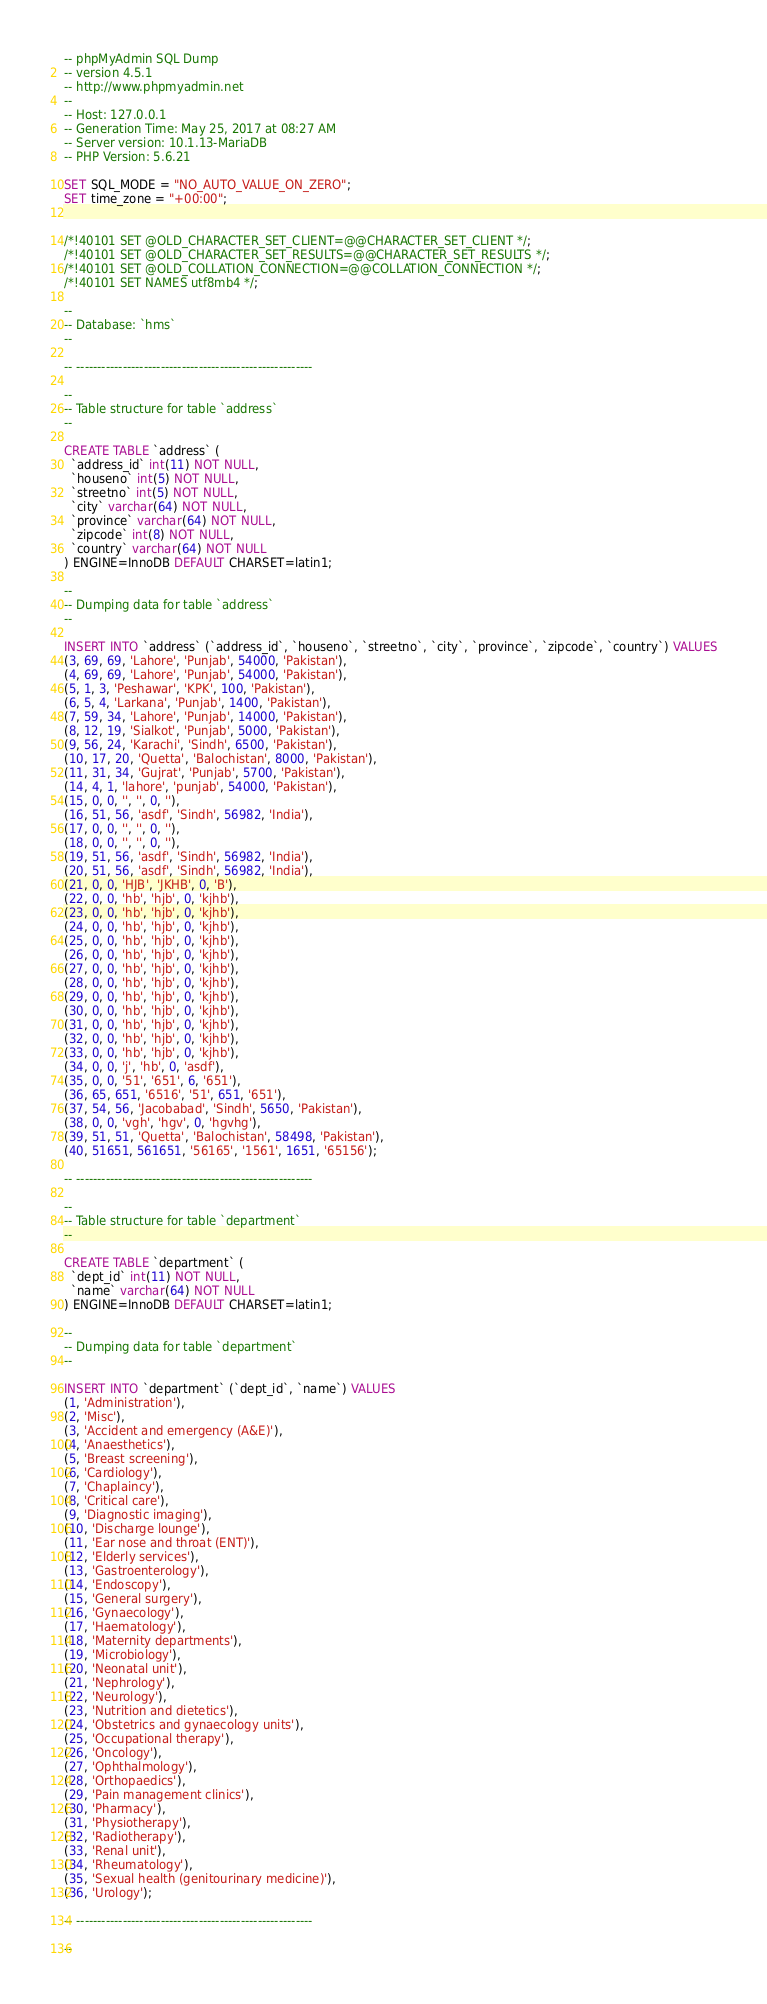<code> <loc_0><loc_0><loc_500><loc_500><_SQL_>-- phpMyAdmin SQL Dump
-- version 4.5.1
-- http://www.phpmyadmin.net
--
-- Host: 127.0.0.1
-- Generation Time: May 25, 2017 at 08:27 AM
-- Server version: 10.1.13-MariaDB
-- PHP Version: 5.6.21

SET SQL_MODE = "NO_AUTO_VALUE_ON_ZERO";
SET time_zone = "+00:00";


/*!40101 SET @OLD_CHARACTER_SET_CLIENT=@@CHARACTER_SET_CLIENT */;
/*!40101 SET @OLD_CHARACTER_SET_RESULTS=@@CHARACTER_SET_RESULTS */;
/*!40101 SET @OLD_COLLATION_CONNECTION=@@COLLATION_CONNECTION */;
/*!40101 SET NAMES utf8mb4 */;

--
-- Database: `hms`
--

-- --------------------------------------------------------

--
-- Table structure for table `address`
--

CREATE TABLE `address` (
  `address_id` int(11) NOT NULL,
  `houseno` int(5) NOT NULL,
  `streetno` int(5) NOT NULL,
  `city` varchar(64) NOT NULL,
  `province` varchar(64) NOT NULL,
  `zipcode` int(8) NOT NULL,
  `country` varchar(64) NOT NULL
) ENGINE=InnoDB DEFAULT CHARSET=latin1;

--
-- Dumping data for table `address`
--

INSERT INTO `address` (`address_id`, `houseno`, `streetno`, `city`, `province`, `zipcode`, `country`) VALUES
(3, 69, 69, 'Lahore', 'Punjab', 54000, 'Pakistan'),
(4, 69, 69, 'Lahore', 'Punjab', 54000, 'Pakistan'),
(5, 1, 3, 'Peshawar', 'KPK', 100, 'Pakistan'),
(6, 5, 4, 'Larkana', 'Punjab', 1400, 'Pakistan'),
(7, 59, 34, 'Lahore', 'Punjab', 14000, 'Pakistan'),
(8, 12, 19, 'Sialkot', 'Punjab', 5000, 'Pakistan'),
(9, 56, 24, 'Karachi', 'Sindh', 6500, 'Pakistan'),
(10, 17, 20, 'Quetta', 'Balochistan', 8000, 'Pakistan'),
(11, 31, 34, 'Gujrat', 'Punjab', 5700, 'Pakistan'),
(14, 4, 1, 'lahore', 'punjab', 54000, 'Pakistan'),
(15, 0, 0, '', '', 0, ''),
(16, 51, 56, 'asdf', 'Sindh', 56982, 'India'),
(17, 0, 0, '', '', 0, ''),
(18, 0, 0, '', '', 0, ''),
(19, 51, 56, 'asdf', 'Sindh', 56982, 'India'),
(20, 51, 56, 'asdf', 'Sindh', 56982, 'India'),
(21, 0, 0, 'HJB', 'JKHB', 0, 'B'),
(22, 0, 0, 'hb', 'hjb', 0, 'kjhb'),
(23, 0, 0, 'hb', 'hjb', 0, 'kjhb'),
(24, 0, 0, 'hb', 'hjb', 0, 'kjhb'),
(25, 0, 0, 'hb', 'hjb', 0, 'kjhb'),
(26, 0, 0, 'hb', 'hjb', 0, 'kjhb'),
(27, 0, 0, 'hb', 'hjb', 0, 'kjhb'),
(28, 0, 0, 'hb', 'hjb', 0, 'kjhb'),
(29, 0, 0, 'hb', 'hjb', 0, 'kjhb'),
(30, 0, 0, 'hb', 'hjb', 0, 'kjhb'),
(31, 0, 0, 'hb', 'hjb', 0, 'kjhb'),
(32, 0, 0, 'hb', 'hjb', 0, 'kjhb'),
(33, 0, 0, 'hb', 'hjb', 0, 'kjhb'),
(34, 0, 0, 'j', 'hb', 0, 'asdf'),
(35, 0, 0, '51', '651', 6, '651'),
(36, 65, 651, '6516', '51', 651, '651'),
(37, 54, 56, 'Jacobabad', 'Sindh', 5650, 'Pakistan'),
(38, 0, 0, 'vgh', 'hgv', 0, 'hgvhg'),
(39, 51, 51, 'Quetta', 'Balochistan', 58498, 'Pakistan'),
(40, 51651, 561651, '56165', '1561', 1651, '65156');

-- --------------------------------------------------------

--
-- Table structure for table `department`
--

CREATE TABLE `department` (
  `dept_id` int(11) NOT NULL,
  `name` varchar(64) NOT NULL
) ENGINE=InnoDB DEFAULT CHARSET=latin1;

--
-- Dumping data for table `department`
--

INSERT INTO `department` (`dept_id`, `name`) VALUES
(1, 'Administration'),
(2, 'Misc'),
(3, 'Accident and emergency (A&E)'),
(4, 'Anaesthetics'),
(5, 'Breast screening'),
(6, 'Cardiology'),
(7, 'Chaplaincy'),
(8, 'Critical care'),
(9, 'Diagnostic imaging'),
(10, 'Discharge lounge'),
(11, 'Ear nose and throat (ENT)'),
(12, 'Elderly services'),
(13, 'Gastroenterology'),
(14, 'Endoscopy'),
(15, 'General surgery'),
(16, 'Gynaecology'),
(17, 'Haematology'),
(18, 'Maternity departments'),
(19, 'Microbiology'),
(20, 'Neonatal unit'),
(21, 'Nephrology'),
(22, 'Neurology'),
(23, 'Nutrition and dietetics'),
(24, 'Obstetrics and gynaecology units'),
(25, 'Occupational therapy'),
(26, 'Oncology'),
(27, 'Ophthalmology'),
(28, 'Orthopaedics'),
(29, 'Pain management clinics'),
(30, 'Pharmacy'),
(31, 'Physiotherapy'),
(32, 'Radiotherapy'),
(33, 'Renal unit'),
(34, 'Rheumatology'),
(35, 'Sexual health (genitourinary medicine)'),
(36, 'Urology');

-- --------------------------------------------------------

--</code> 